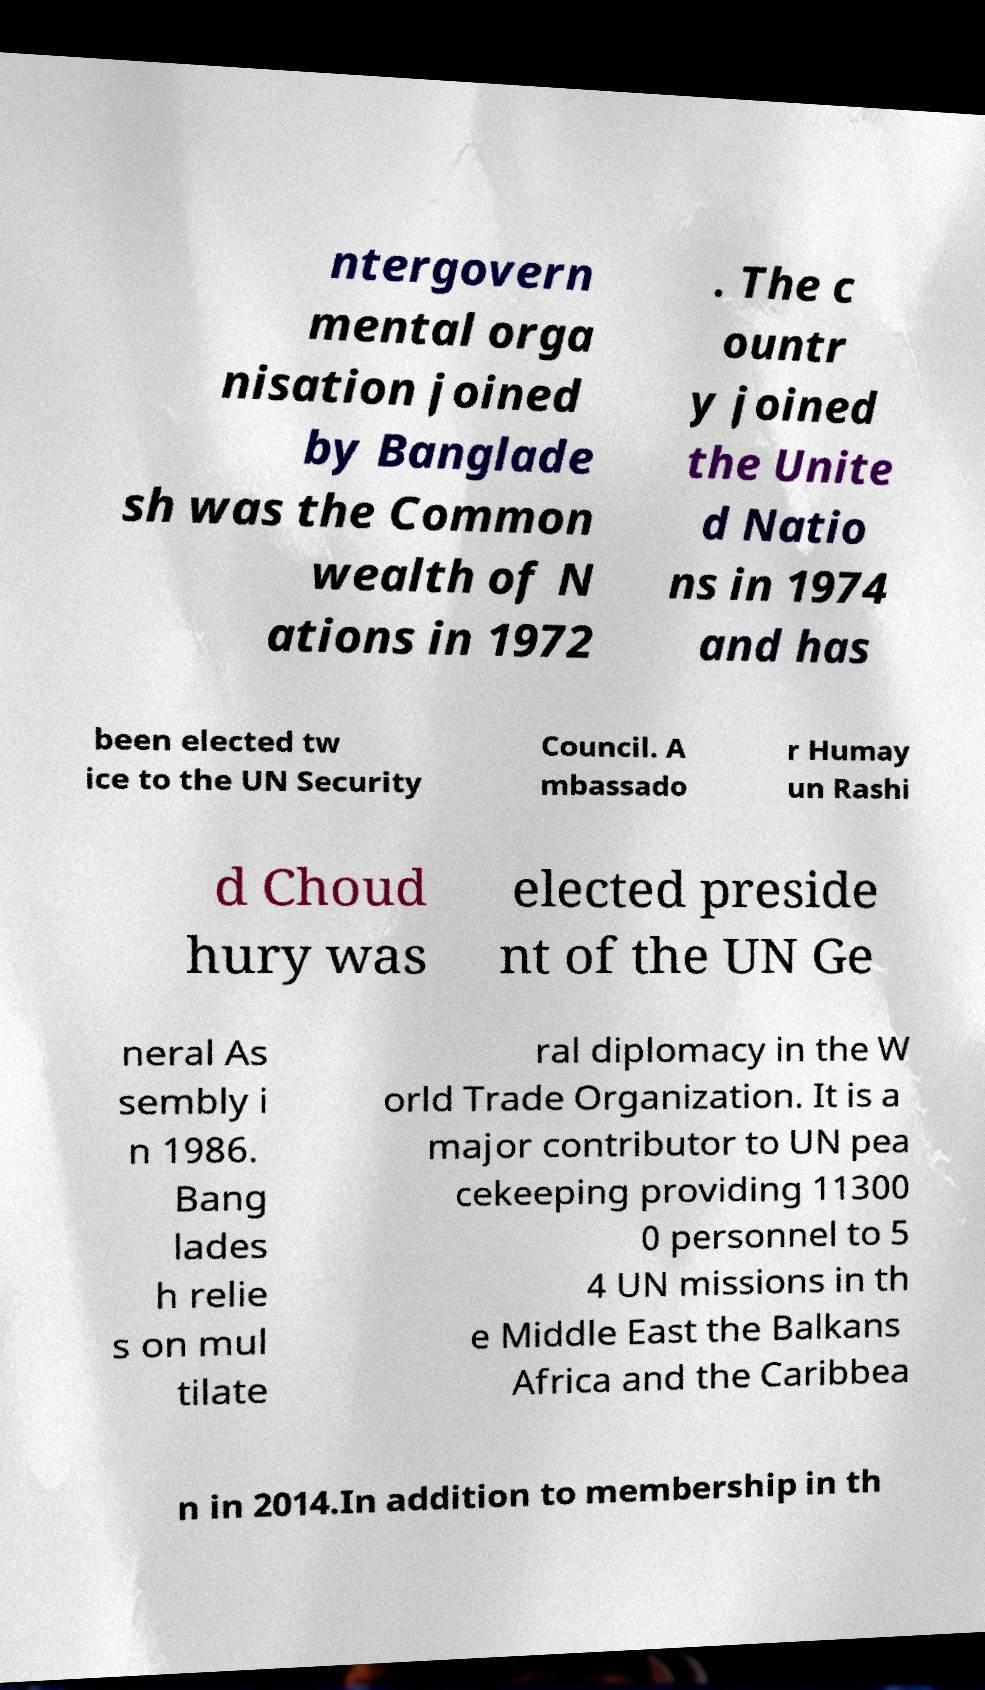Can you read and provide the text displayed in the image?This photo seems to have some interesting text. Can you extract and type it out for me? ntergovern mental orga nisation joined by Banglade sh was the Common wealth of N ations in 1972 . The c ountr y joined the Unite d Natio ns in 1974 and has been elected tw ice to the UN Security Council. A mbassado r Humay un Rashi d Choud hury was elected preside nt of the UN Ge neral As sembly i n 1986. Bang lades h relie s on mul tilate ral diplomacy in the W orld Trade Organization. It is a major contributor to UN pea cekeeping providing 11300 0 personnel to 5 4 UN missions in th e Middle East the Balkans Africa and the Caribbea n in 2014.In addition to membership in th 